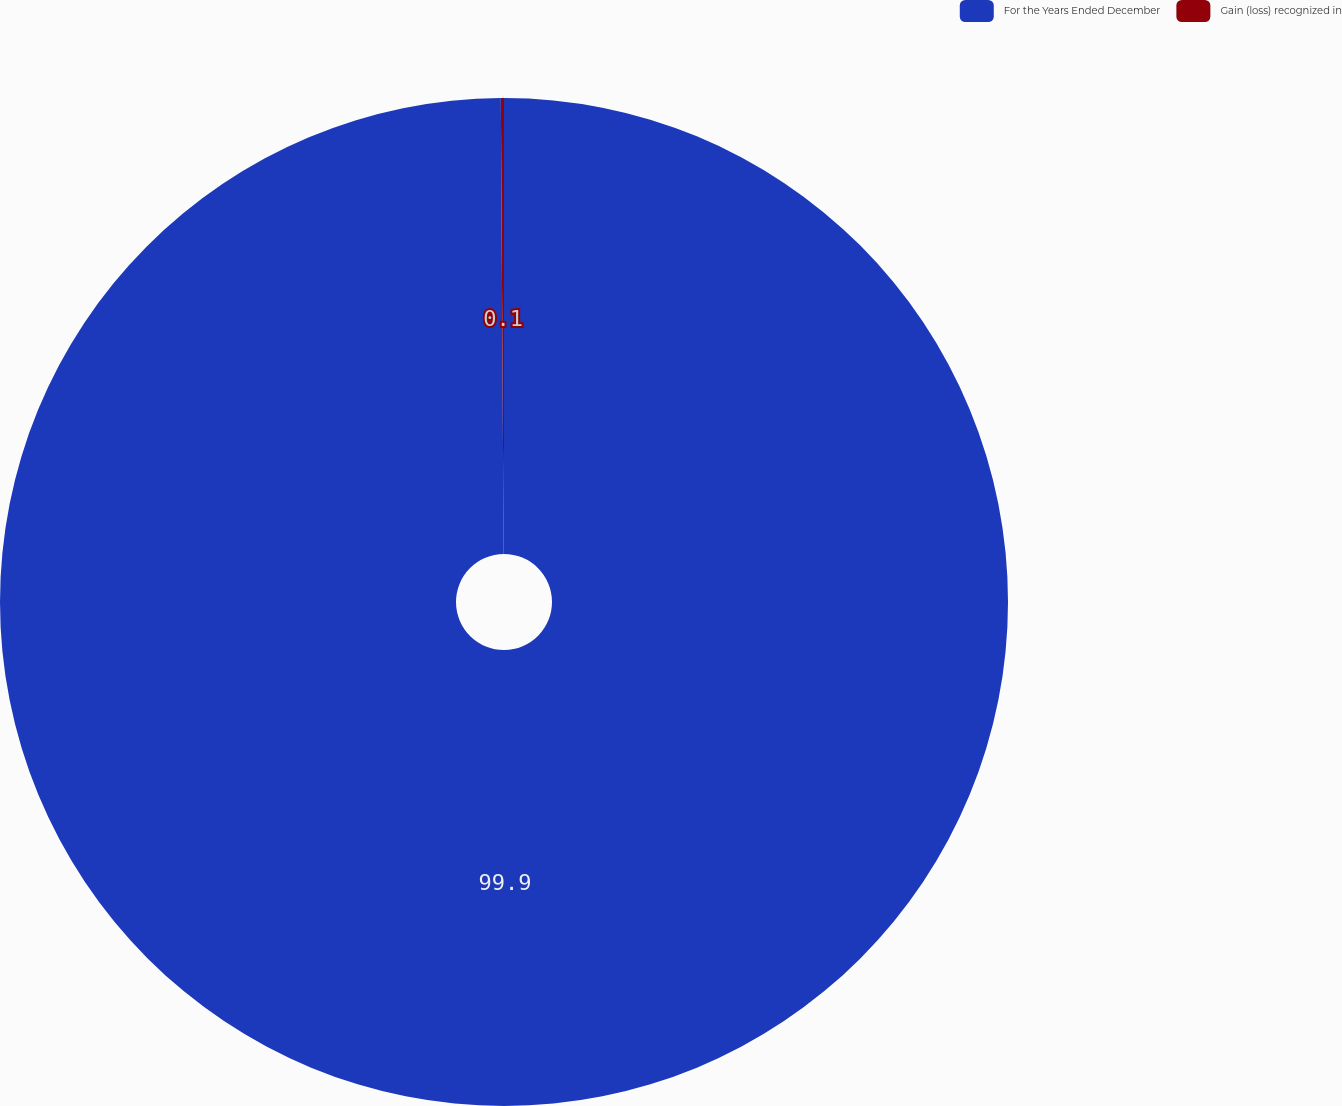<chart> <loc_0><loc_0><loc_500><loc_500><pie_chart><fcel>For the Years Ended December<fcel>Gain (loss) recognized in<nl><fcel>99.9%<fcel>0.1%<nl></chart> 